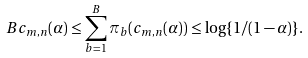Convert formula to latex. <formula><loc_0><loc_0><loc_500><loc_500>B c _ { m , n } ( \alpha ) \leq \sum _ { b = 1 } ^ { B } \pi _ { b } ( c _ { m , n } ( \alpha ) ) \leq \log \{ 1 / ( 1 - \alpha ) \} .</formula> 